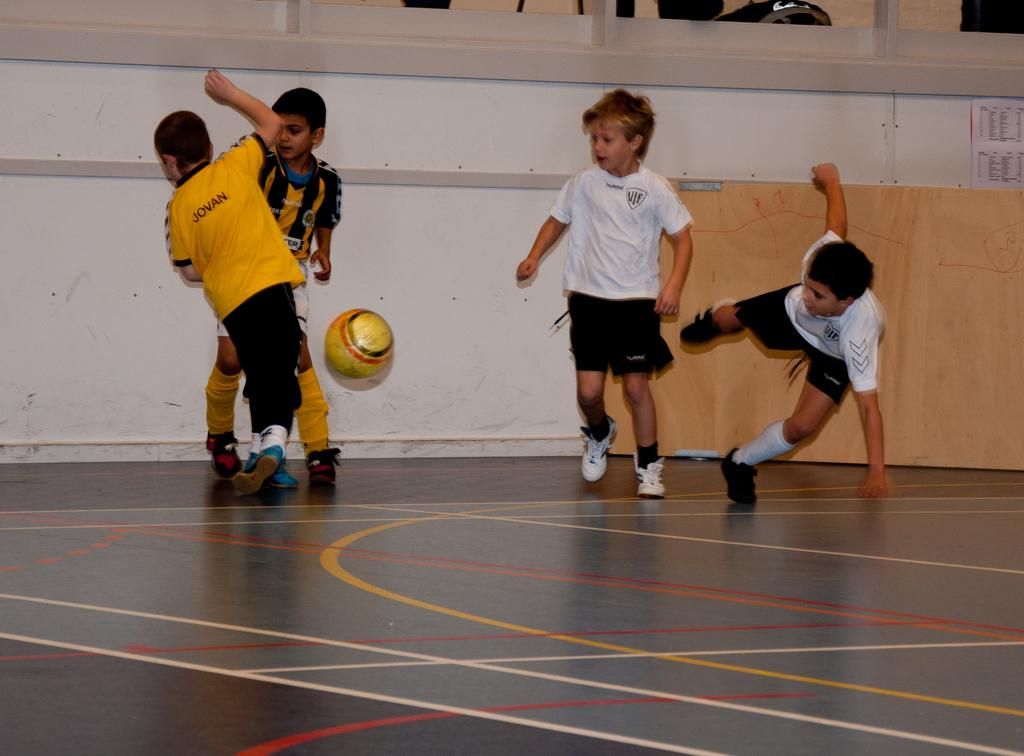Who is present in the image? There are children in the image. What activity are the children engaged in? The children are playing football. What type of care is the football receiving in the image? There is no indication of care being provided to the football in the image. Can you see any badges on the children's clothing in the image? There is no mention of badges on the children's clothing in the provided facts, so we cannot determine if any are present. 